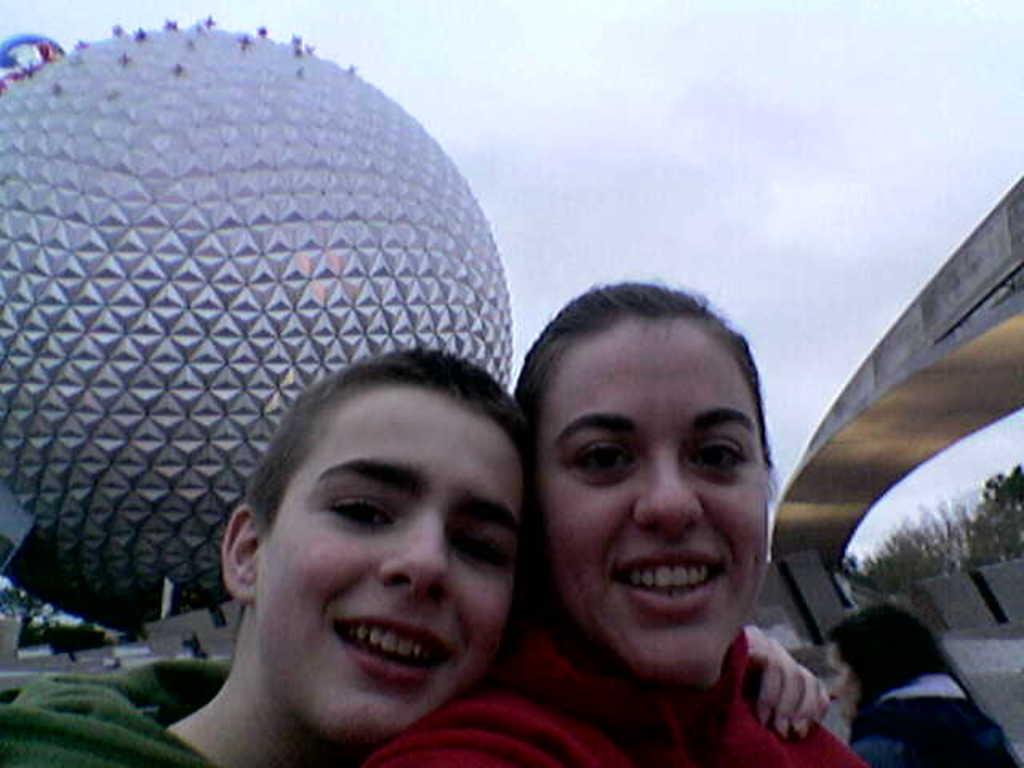How many people are in the image? There are three persons in the image. What is located behind the persons? There is a big ball behind the persons. What type of natural elements can be seen in the image? Trees are visible in the image. What is visible in the background of the image? The sky is visible in the image. What type of hen can be seen sitting on the chin of one of the persons in the image? There is no hen or chin visible in the image; it only features three persons and a big ball. 